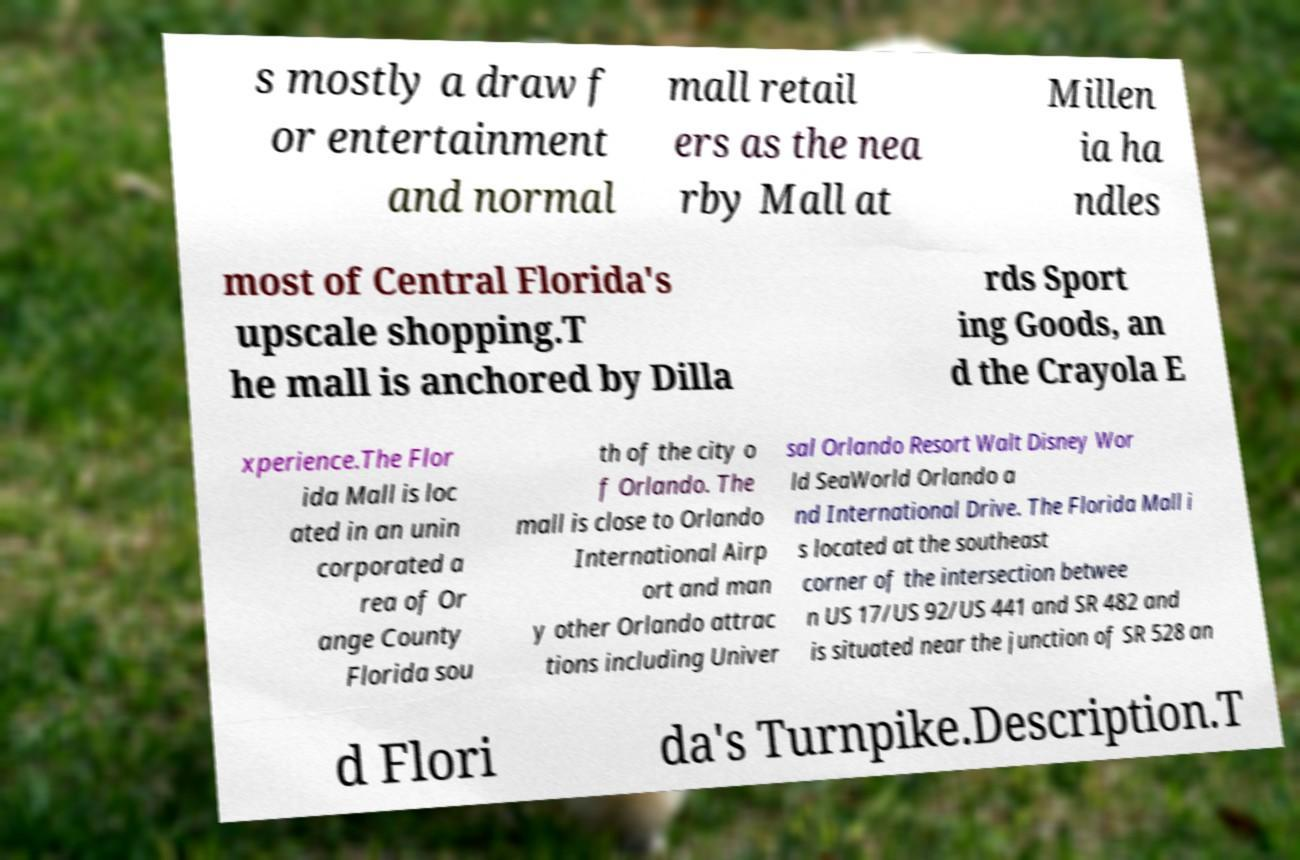Please read and relay the text visible in this image. What does it say? s mostly a draw f or entertainment and normal mall retail ers as the nea rby Mall at Millen ia ha ndles most of Central Florida's upscale shopping.T he mall is anchored by Dilla rds Sport ing Goods, an d the Crayola E xperience.The Flor ida Mall is loc ated in an unin corporated a rea of Or ange County Florida sou th of the city o f Orlando. The mall is close to Orlando International Airp ort and man y other Orlando attrac tions including Univer sal Orlando Resort Walt Disney Wor ld SeaWorld Orlando a nd International Drive. The Florida Mall i s located at the southeast corner of the intersection betwee n US 17/US 92/US 441 and SR 482 and is situated near the junction of SR 528 an d Flori da's Turnpike.Description.T 